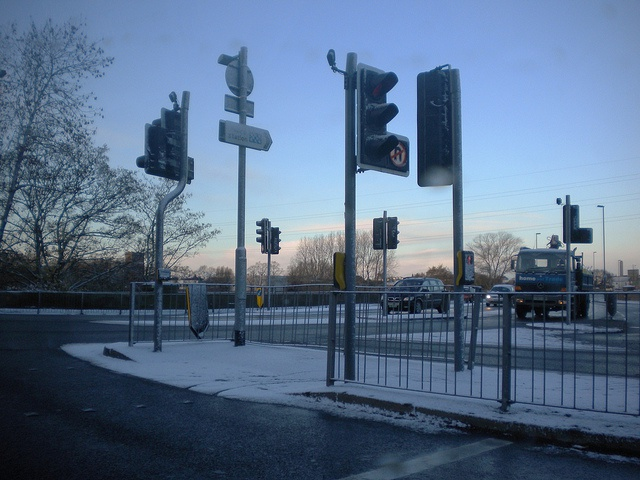Describe the objects in this image and their specific colors. I can see truck in gray, black, navy, and blue tones, traffic light in gray, navy, black, and blue tones, traffic light in gray, navy, black, and blue tones, traffic light in gray, navy, black, and blue tones, and car in gray, black, navy, and blue tones in this image. 